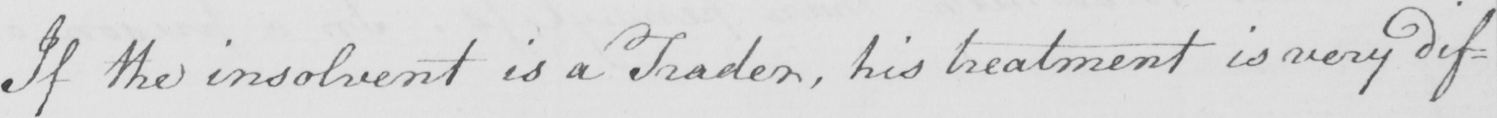What does this handwritten line say? If the insolvent is a Trader , his treatment is very dif= 